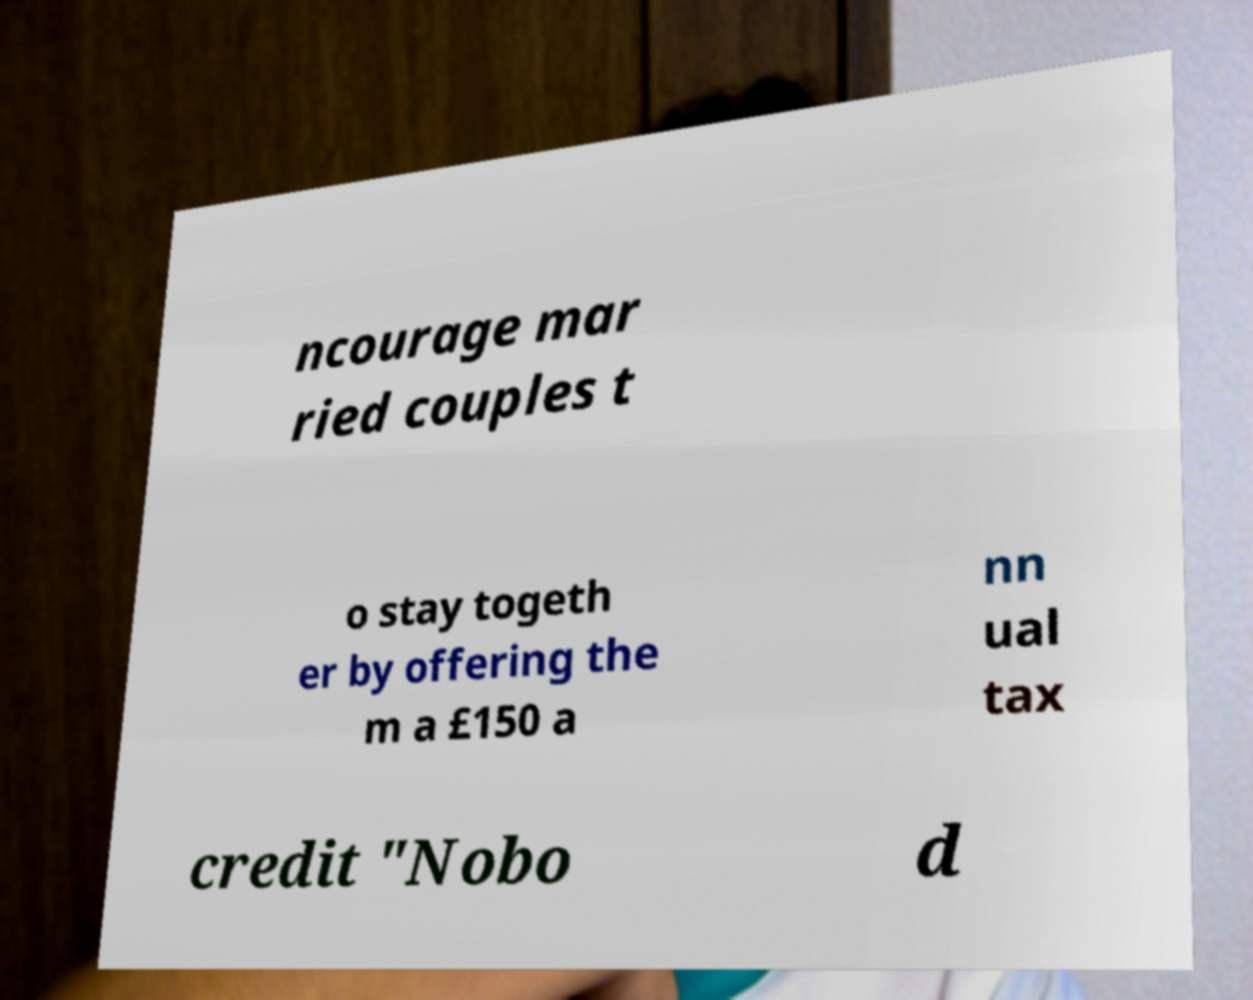I need the written content from this picture converted into text. Can you do that? ncourage mar ried couples t o stay togeth er by offering the m a £150 a nn ual tax credit "Nobo d 